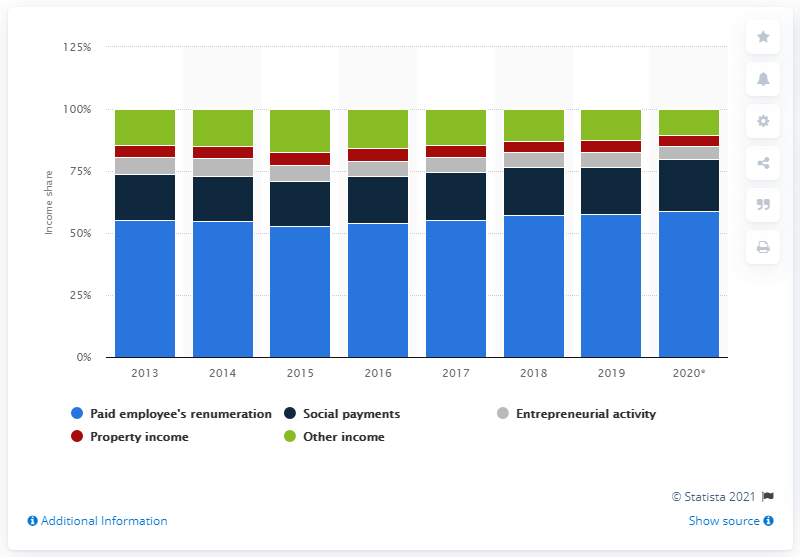Point out several critical features in this image. According to data from 2020, approximately 58.9% of the Russian population's income was derived from employee remuneration. 